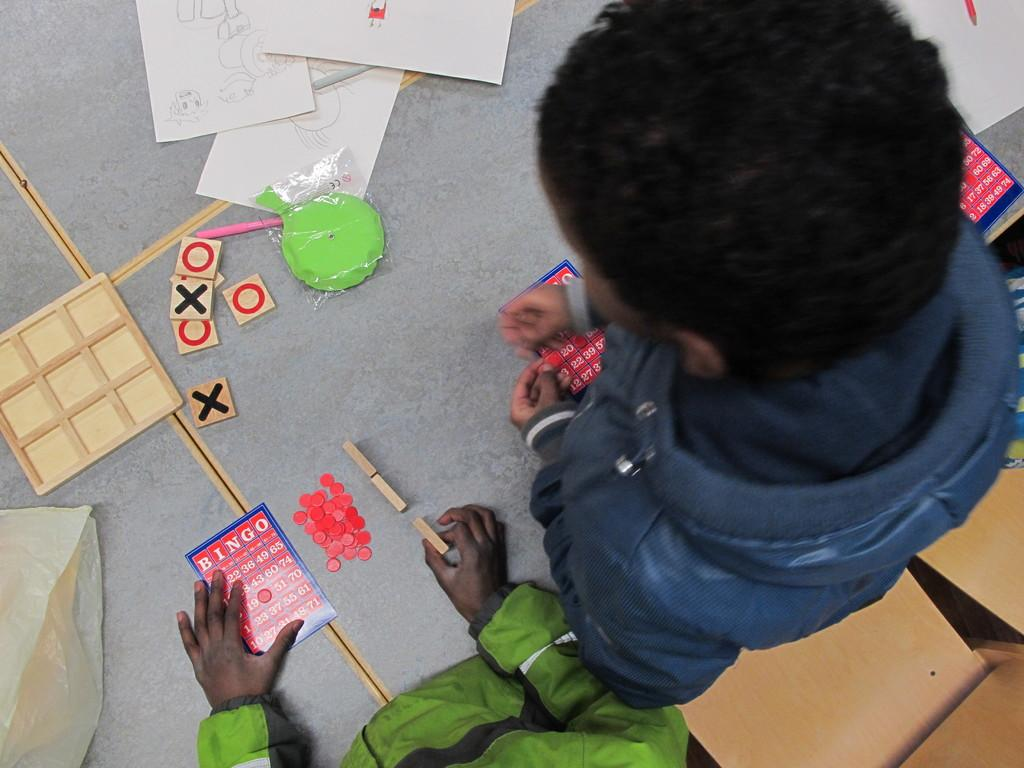What is the primary action of the boy in the image? The boy is standing in the image. What is the seated person doing in the image? The seated person is playing a bingo game on the floor. What objects are visible in the image that are related to the bingo game? There are papers visible in the image, which are likely related to the bingo game. What type of furniture is present in the image? There are chairs present in the image. What is the opinion of the boy about the ongoing war in the image? There is no mention of a war or any related opinions in the image. The boy is simply standing, and the seated person is playing a bingo game. 